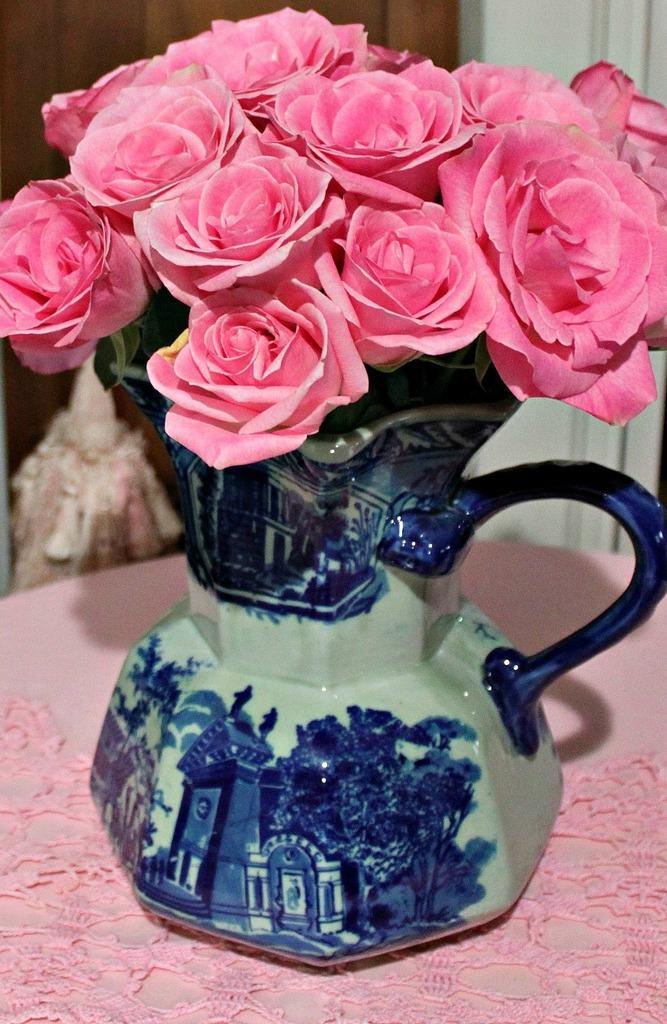Could you give a brief overview of what you see in this image? In this image we can see some rose flowers in a flower pot which is placed on the table. 